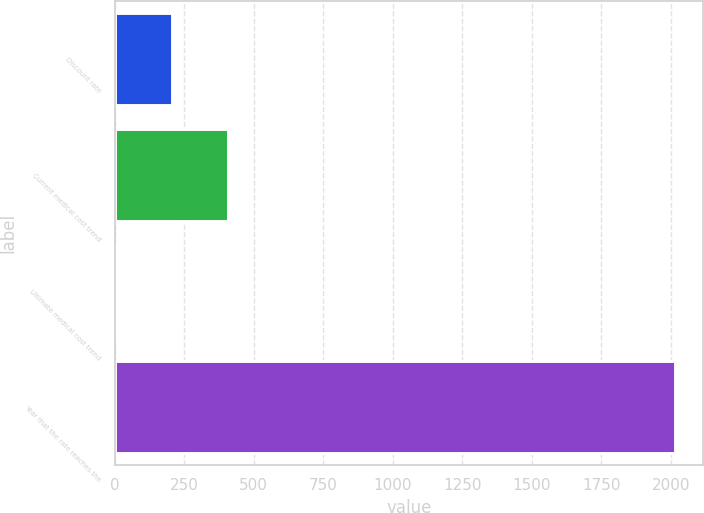Convert chart to OTSL. <chart><loc_0><loc_0><loc_500><loc_500><bar_chart><fcel>Discount rate<fcel>Current medical cost trend<fcel>Ultimate medical cost trend<fcel>Year that the rate reaches the<nl><fcel>206.1<fcel>407.2<fcel>5<fcel>2016<nl></chart> 